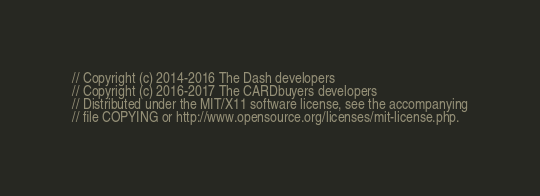Convert code to text. <code><loc_0><loc_0><loc_500><loc_500><_C++_>// Copyright (c) 2014-2016 The Dash developers
// Copyright (c) 2016-2017 The CARDbuyers developers
// Distributed under the MIT/X11 software license, see the accompanying
// file COPYING or http://www.opensource.org/licenses/mit-license.php.
</code> 